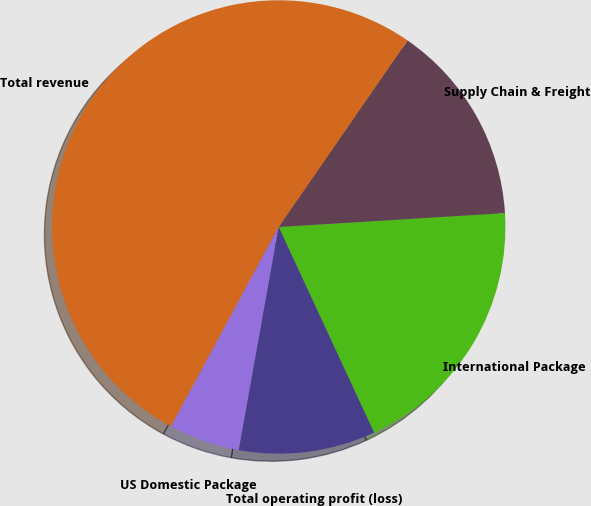Convert chart to OTSL. <chart><loc_0><loc_0><loc_500><loc_500><pie_chart><fcel>International Package<fcel>Supply Chain & Freight<fcel>Total revenue<fcel>US Domestic Package<fcel>Total operating profit (loss)<nl><fcel>19.07%<fcel>14.4%<fcel>51.75%<fcel>5.06%<fcel>9.73%<nl></chart> 